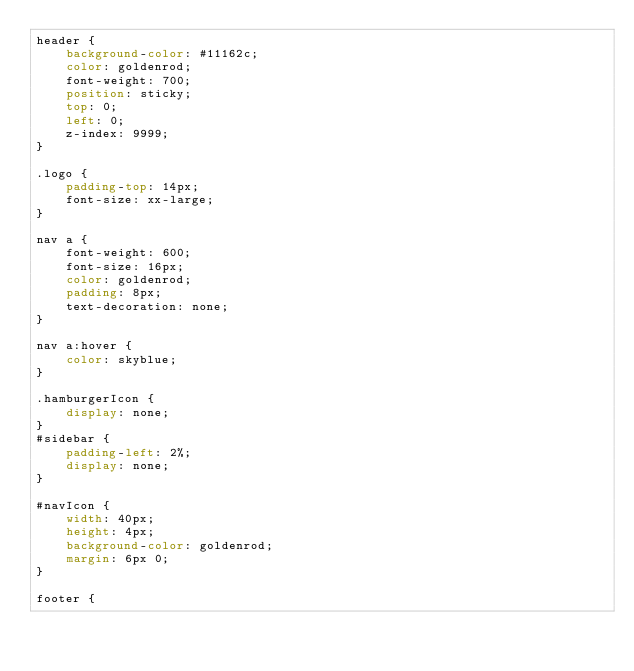<code> <loc_0><loc_0><loc_500><loc_500><_CSS_>header {
    background-color: #11162c;
    color: goldenrod;
    font-weight: 700;
    position: sticky;
    top: 0;
    left: 0;
    z-index: 9999;
}

.logo {
    padding-top: 14px;
    font-size: xx-large;
}

nav a {
    font-weight: 600;
    font-size: 16px;
    color: goldenrod;
    padding: 8px;
    text-decoration: none;
}

nav a:hover {
    color: skyblue;
}

.hamburgerIcon {
    display: none;
}
#sidebar {
    padding-left: 2%;
    display: none;
}

#navIcon {
    width: 40px;
    height: 4px;
    background-color: goldenrod;
    margin: 6px 0;
}

footer {</code> 